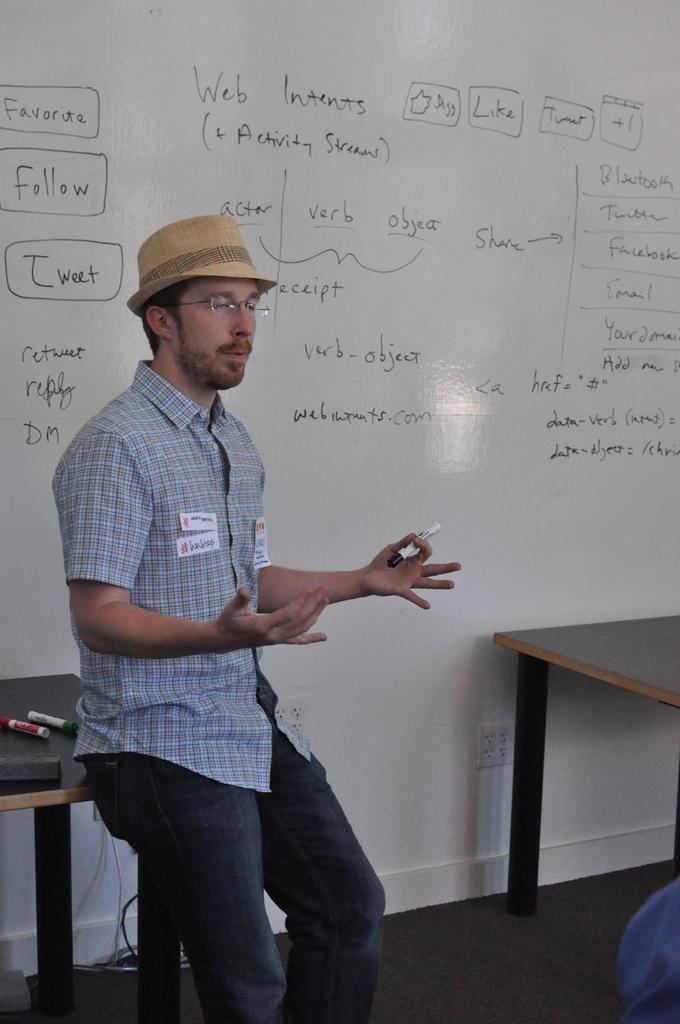What goes with the actor and the verb?
Give a very brief answer. Object. 